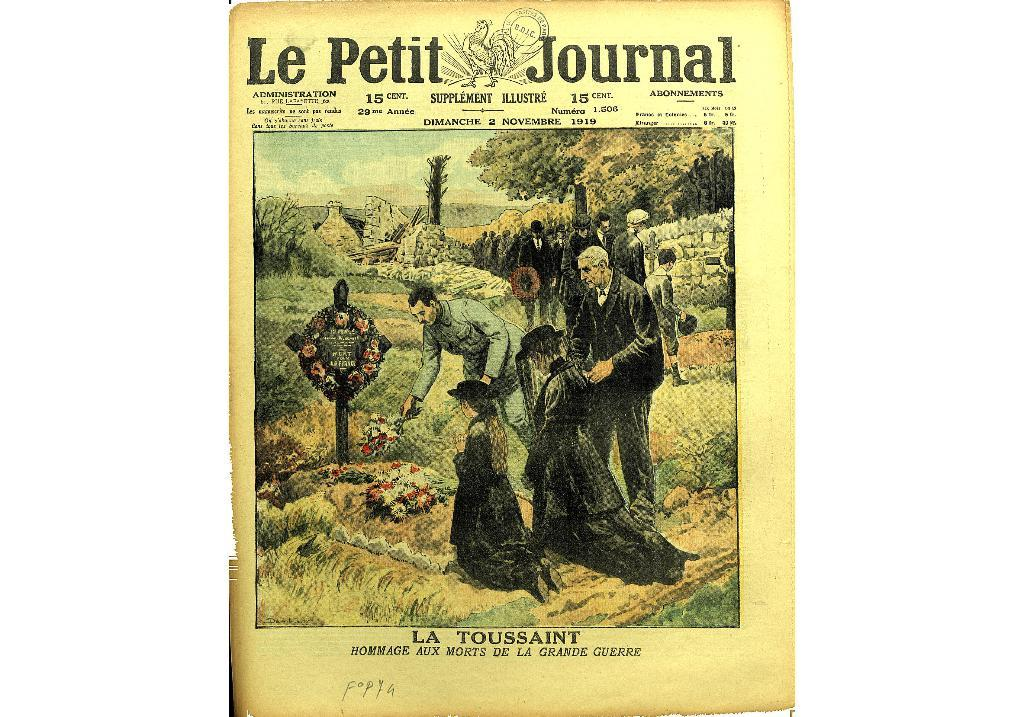<image>
Summarize the visual content of the image. An old cover for the Le Petit Journal showing a funeral. 